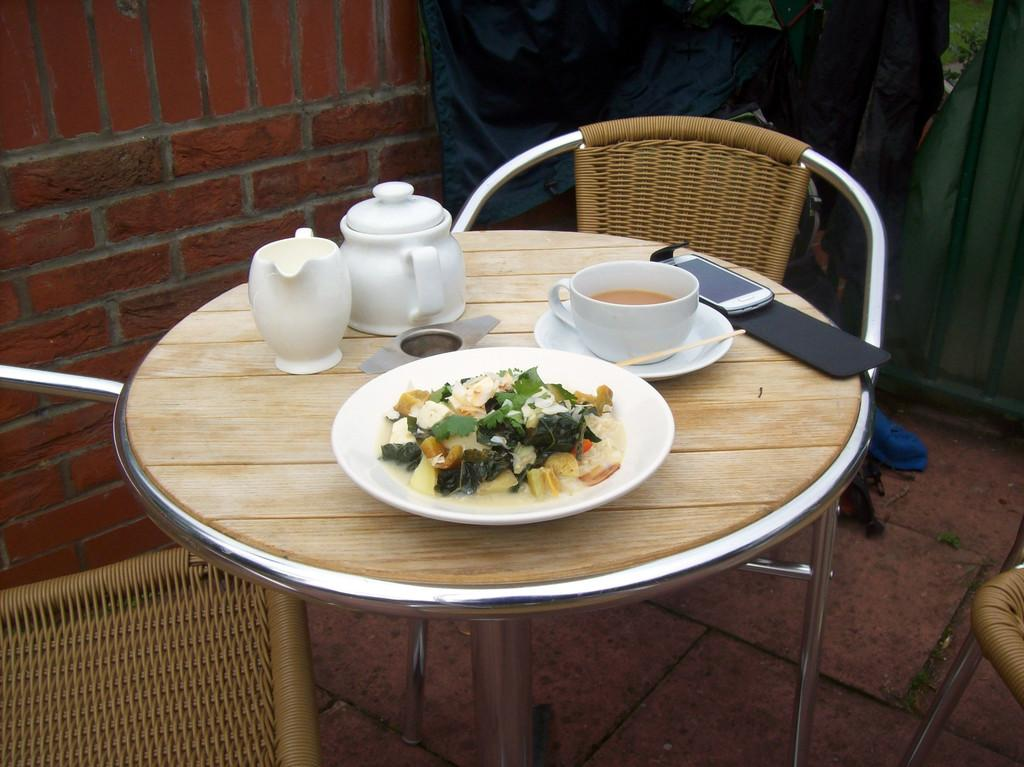What piece of furniture is present in the image? There is a table in the image. What is on the table? There is a plate with food, a coffee cup, a mobile, and a jar on the table. Are there any chairs in the image? Yes, there are chairs on the right and left sides of the table. What can be seen in the background of the image? There is a brick wall in the background. How does the flock of birds interact with the table in the image? There are no birds, let alone a flock of birds, present in the image. What type of care is being provided to the table in the image? There is no indication of any care being provided to the table in the image. 